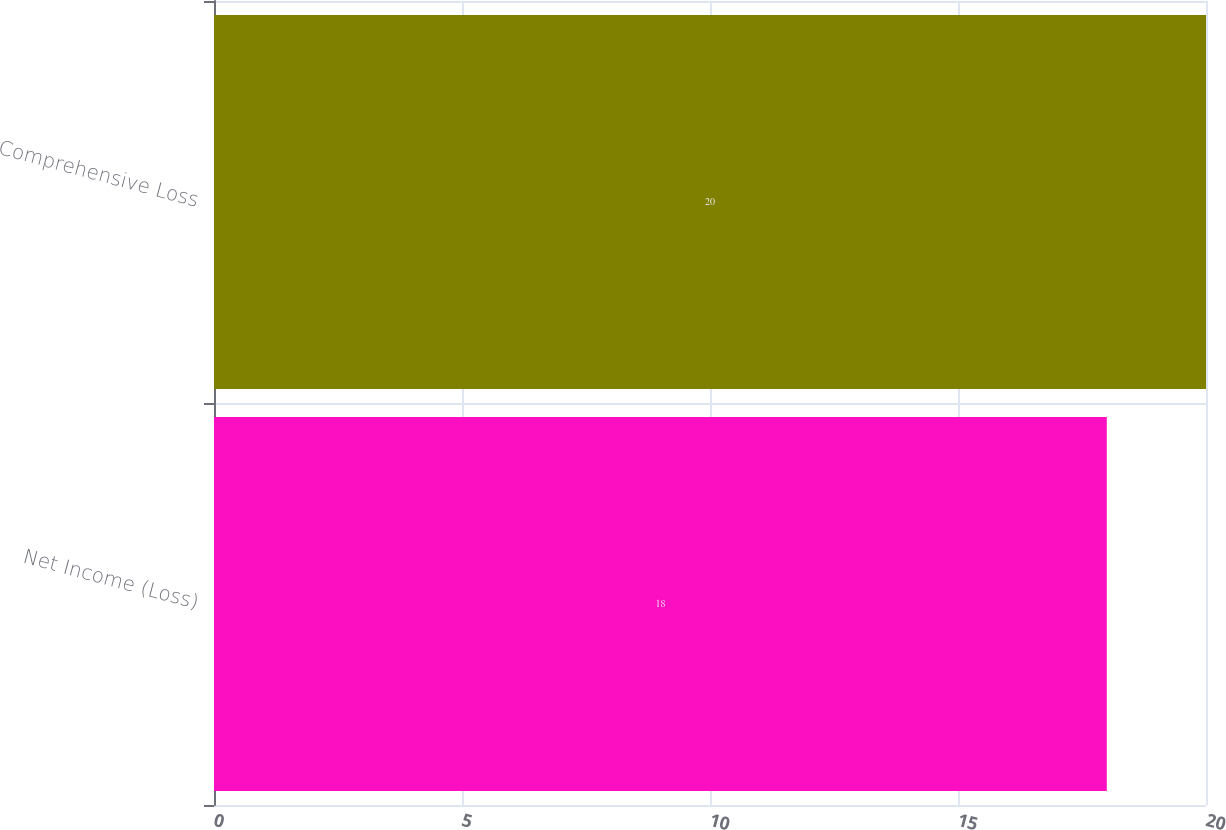<chart> <loc_0><loc_0><loc_500><loc_500><bar_chart><fcel>Net Income (Loss)<fcel>Comprehensive Loss<nl><fcel>18<fcel>20<nl></chart> 